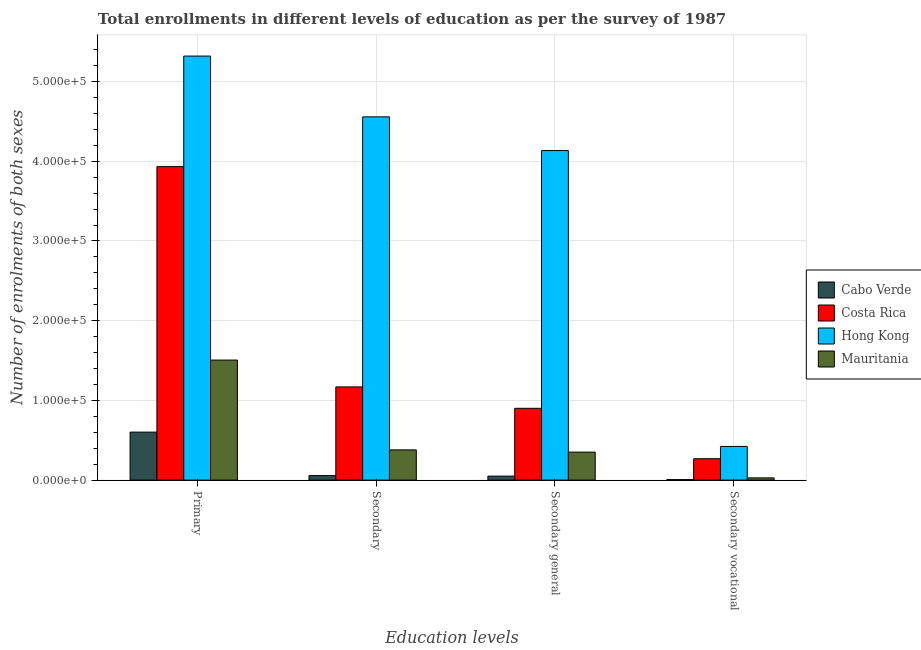How many different coloured bars are there?
Provide a short and direct response. 4. How many groups of bars are there?
Your response must be concise. 4. Are the number of bars per tick equal to the number of legend labels?
Provide a short and direct response. Yes. What is the label of the 2nd group of bars from the left?
Your response must be concise. Secondary. What is the number of enrolments in secondary general education in Costa Rica?
Offer a terse response. 9.01e+04. Across all countries, what is the maximum number of enrolments in secondary vocational education?
Your answer should be compact. 4.23e+04. Across all countries, what is the minimum number of enrolments in secondary education?
Provide a succinct answer. 5675. In which country was the number of enrolments in primary education maximum?
Make the answer very short. Hong Kong. In which country was the number of enrolments in secondary education minimum?
Offer a terse response. Cabo Verde. What is the total number of enrolments in primary education in the graph?
Keep it short and to the point. 1.14e+06. What is the difference between the number of enrolments in primary education in Cabo Verde and that in Costa Rica?
Provide a short and direct response. -3.33e+05. What is the difference between the number of enrolments in primary education in Mauritania and the number of enrolments in secondary general education in Cabo Verde?
Give a very brief answer. 1.46e+05. What is the average number of enrolments in primary education per country?
Ensure brevity in your answer.  2.84e+05. What is the difference between the number of enrolments in secondary general education and number of enrolments in primary education in Costa Rica?
Give a very brief answer. -3.03e+05. In how many countries, is the number of enrolments in primary education greater than 380000 ?
Your answer should be very brief. 2. What is the ratio of the number of enrolments in secondary general education in Cabo Verde to that in Costa Rica?
Your response must be concise. 0.06. Is the difference between the number of enrolments in secondary general education in Hong Kong and Costa Rica greater than the difference between the number of enrolments in secondary education in Hong Kong and Costa Rica?
Provide a short and direct response. No. What is the difference between the highest and the second highest number of enrolments in primary education?
Provide a succinct answer. 1.39e+05. What is the difference between the highest and the lowest number of enrolments in secondary education?
Your answer should be compact. 4.50e+05. In how many countries, is the number of enrolments in primary education greater than the average number of enrolments in primary education taken over all countries?
Your answer should be compact. 2. Is the sum of the number of enrolments in secondary education in Mauritania and Hong Kong greater than the maximum number of enrolments in secondary vocational education across all countries?
Provide a succinct answer. Yes. What does the 3rd bar from the left in Secondary vocational represents?
Your response must be concise. Hong Kong. What does the 1st bar from the right in Secondary represents?
Provide a short and direct response. Mauritania. Is it the case that in every country, the sum of the number of enrolments in primary education and number of enrolments in secondary education is greater than the number of enrolments in secondary general education?
Your response must be concise. Yes. Are the values on the major ticks of Y-axis written in scientific E-notation?
Offer a terse response. Yes. Where does the legend appear in the graph?
Your answer should be very brief. Center right. How many legend labels are there?
Your answer should be very brief. 4. What is the title of the graph?
Provide a short and direct response. Total enrollments in different levels of education as per the survey of 1987. What is the label or title of the X-axis?
Offer a very short reply. Education levels. What is the label or title of the Y-axis?
Keep it short and to the point. Number of enrolments of both sexes. What is the Number of enrolments of both sexes in Cabo Verde in Primary?
Your answer should be very brief. 6.02e+04. What is the Number of enrolments of both sexes in Costa Rica in Primary?
Your answer should be compact. 3.93e+05. What is the Number of enrolments of both sexes in Hong Kong in Primary?
Your answer should be compact. 5.32e+05. What is the Number of enrolments of both sexes of Mauritania in Primary?
Make the answer very short. 1.51e+05. What is the Number of enrolments of both sexes of Cabo Verde in Secondary?
Give a very brief answer. 5675. What is the Number of enrolments of both sexes in Costa Rica in Secondary?
Offer a very short reply. 1.17e+05. What is the Number of enrolments of both sexes in Hong Kong in Secondary?
Offer a very short reply. 4.56e+05. What is the Number of enrolments of both sexes in Mauritania in Secondary?
Keep it short and to the point. 3.79e+04. What is the Number of enrolments of both sexes in Cabo Verde in Secondary general?
Ensure brevity in your answer.  5026. What is the Number of enrolments of both sexes in Costa Rica in Secondary general?
Make the answer very short. 9.01e+04. What is the Number of enrolments of both sexes of Hong Kong in Secondary general?
Give a very brief answer. 4.13e+05. What is the Number of enrolments of both sexes in Mauritania in Secondary general?
Offer a very short reply. 3.51e+04. What is the Number of enrolments of both sexes in Cabo Verde in Secondary vocational?
Your answer should be compact. 649. What is the Number of enrolments of both sexes of Costa Rica in Secondary vocational?
Provide a short and direct response. 2.68e+04. What is the Number of enrolments of both sexes in Hong Kong in Secondary vocational?
Your response must be concise. 4.23e+04. What is the Number of enrolments of both sexes in Mauritania in Secondary vocational?
Ensure brevity in your answer.  2808. Across all Education levels, what is the maximum Number of enrolments of both sexes of Cabo Verde?
Offer a terse response. 6.02e+04. Across all Education levels, what is the maximum Number of enrolments of both sexes of Costa Rica?
Ensure brevity in your answer.  3.93e+05. Across all Education levels, what is the maximum Number of enrolments of both sexes of Hong Kong?
Offer a terse response. 5.32e+05. Across all Education levels, what is the maximum Number of enrolments of both sexes of Mauritania?
Your response must be concise. 1.51e+05. Across all Education levels, what is the minimum Number of enrolments of both sexes of Cabo Verde?
Give a very brief answer. 649. Across all Education levels, what is the minimum Number of enrolments of both sexes in Costa Rica?
Your answer should be compact. 2.68e+04. Across all Education levels, what is the minimum Number of enrolments of both sexes of Hong Kong?
Make the answer very short. 4.23e+04. Across all Education levels, what is the minimum Number of enrolments of both sexes of Mauritania?
Keep it short and to the point. 2808. What is the total Number of enrolments of both sexes of Cabo Verde in the graph?
Your answer should be compact. 7.16e+04. What is the total Number of enrolments of both sexes in Costa Rica in the graph?
Give a very brief answer. 6.27e+05. What is the total Number of enrolments of both sexes in Hong Kong in the graph?
Give a very brief answer. 1.44e+06. What is the total Number of enrolments of both sexes in Mauritania in the graph?
Offer a terse response. 2.26e+05. What is the difference between the Number of enrolments of both sexes in Cabo Verde in Primary and that in Secondary?
Your answer should be compact. 5.46e+04. What is the difference between the Number of enrolments of both sexes of Costa Rica in Primary and that in Secondary?
Your response must be concise. 2.76e+05. What is the difference between the Number of enrolments of both sexes of Hong Kong in Primary and that in Secondary?
Offer a very short reply. 7.63e+04. What is the difference between the Number of enrolments of both sexes of Mauritania in Primary and that in Secondary?
Make the answer very short. 1.13e+05. What is the difference between the Number of enrolments of both sexes in Cabo Verde in Primary and that in Secondary general?
Offer a terse response. 5.52e+04. What is the difference between the Number of enrolments of both sexes of Costa Rica in Primary and that in Secondary general?
Provide a short and direct response. 3.03e+05. What is the difference between the Number of enrolments of both sexes in Hong Kong in Primary and that in Secondary general?
Provide a succinct answer. 1.19e+05. What is the difference between the Number of enrolments of both sexes in Mauritania in Primary and that in Secondary general?
Provide a succinct answer. 1.15e+05. What is the difference between the Number of enrolments of both sexes in Cabo Verde in Primary and that in Secondary vocational?
Keep it short and to the point. 5.96e+04. What is the difference between the Number of enrolments of both sexes in Costa Rica in Primary and that in Secondary vocational?
Give a very brief answer. 3.66e+05. What is the difference between the Number of enrolments of both sexes in Hong Kong in Primary and that in Secondary vocational?
Offer a very short reply. 4.90e+05. What is the difference between the Number of enrolments of both sexes of Mauritania in Primary and that in Secondary vocational?
Offer a terse response. 1.48e+05. What is the difference between the Number of enrolments of both sexes of Cabo Verde in Secondary and that in Secondary general?
Your answer should be very brief. 649. What is the difference between the Number of enrolments of both sexes of Costa Rica in Secondary and that in Secondary general?
Ensure brevity in your answer.  2.68e+04. What is the difference between the Number of enrolments of both sexes of Hong Kong in Secondary and that in Secondary general?
Keep it short and to the point. 4.23e+04. What is the difference between the Number of enrolments of both sexes of Mauritania in Secondary and that in Secondary general?
Offer a very short reply. 2808. What is the difference between the Number of enrolments of both sexes of Cabo Verde in Secondary and that in Secondary vocational?
Offer a terse response. 5026. What is the difference between the Number of enrolments of both sexes of Costa Rica in Secondary and that in Secondary vocational?
Offer a very short reply. 9.01e+04. What is the difference between the Number of enrolments of both sexes in Hong Kong in Secondary and that in Secondary vocational?
Your response must be concise. 4.13e+05. What is the difference between the Number of enrolments of both sexes of Mauritania in Secondary and that in Secondary vocational?
Make the answer very short. 3.51e+04. What is the difference between the Number of enrolments of both sexes in Cabo Verde in Secondary general and that in Secondary vocational?
Make the answer very short. 4377. What is the difference between the Number of enrolments of both sexes in Costa Rica in Secondary general and that in Secondary vocational?
Provide a succinct answer. 6.33e+04. What is the difference between the Number of enrolments of both sexes in Hong Kong in Secondary general and that in Secondary vocational?
Your response must be concise. 3.71e+05. What is the difference between the Number of enrolments of both sexes in Mauritania in Secondary general and that in Secondary vocational?
Ensure brevity in your answer.  3.23e+04. What is the difference between the Number of enrolments of both sexes of Cabo Verde in Primary and the Number of enrolments of both sexes of Costa Rica in Secondary?
Your response must be concise. -5.67e+04. What is the difference between the Number of enrolments of both sexes in Cabo Verde in Primary and the Number of enrolments of both sexes in Hong Kong in Secondary?
Offer a terse response. -3.96e+05. What is the difference between the Number of enrolments of both sexes in Cabo Verde in Primary and the Number of enrolments of both sexes in Mauritania in Secondary?
Your response must be concise. 2.23e+04. What is the difference between the Number of enrolments of both sexes of Costa Rica in Primary and the Number of enrolments of both sexes of Hong Kong in Secondary?
Provide a short and direct response. -6.24e+04. What is the difference between the Number of enrolments of both sexes of Costa Rica in Primary and the Number of enrolments of both sexes of Mauritania in Secondary?
Provide a short and direct response. 3.55e+05. What is the difference between the Number of enrolments of both sexes in Hong Kong in Primary and the Number of enrolments of both sexes in Mauritania in Secondary?
Keep it short and to the point. 4.94e+05. What is the difference between the Number of enrolments of both sexes of Cabo Verde in Primary and the Number of enrolments of both sexes of Costa Rica in Secondary general?
Offer a very short reply. -2.99e+04. What is the difference between the Number of enrolments of both sexes of Cabo Verde in Primary and the Number of enrolments of both sexes of Hong Kong in Secondary general?
Your answer should be very brief. -3.53e+05. What is the difference between the Number of enrolments of both sexes of Cabo Verde in Primary and the Number of enrolments of both sexes of Mauritania in Secondary general?
Your answer should be compact. 2.51e+04. What is the difference between the Number of enrolments of both sexes in Costa Rica in Primary and the Number of enrolments of both sexes in Hong Kong in Secondary general?
Ensure brevity in your answer.  -2.02e+04. What is the difference between the Number of enrolments of both sexes in Costa Rica in Primary and the Number of enrolments of both sexes in Mauritania in Secondary general?
Offer a terse response. 3.58e+05. What is the difference between the Number of enrolments of both sexes in Hong Kong in Primary and the Number of enrolments of both sexes in Mauritania in Secondary general?
Your response must be concise. 4.97e+05. What is the difference between the Number of enrolments of both sexes of Cabo Verde in Primary and the Number of enrolments of both sexes of Costa Rica in Secondary vocational?
Provide a short and direct response. 3.34e+04. What is the difference between the Number of enrolments of both sexes in Cabo Verde in Primary and the Number of enrolments of both sexes in Hong Kong in Secondary vocational?
Offer a very short reply. 1.80e+04. What is the difference between the Number of enrolments of both sexes of Cabo Verde in Primary and the Number of enrolments of both sexes of Mauritania in Secondary vocational?
Offer a very short reply. 5.74e+04. What is the difference between the Number of enrolments of both sexes of Costa Rica in Primary and the Number of enrolments of both sexes of Hong Kong in Secondary vocational?
Keep it short and to the point. 3.51e+05. What is the difference between the Number of enrolments of both sexes of Costa Rica in Primary and the Number of enrolments of both sexes of Mauritania in Secondary vocational?
Your response must be concise. 3.90e+05. What is the difference between the Number of enrolments of both sexes of Hong Kong in Primary and the Number of enrolments of both sexes of Mauritania in Secondary vocational?
Provide a short and direct response. 5.29e+05. What is the difference between the Number of enrolments of both sexes in Cabo Verde in Secondary and the Number of enrolments of both sexes in Costa Rica in Secondary general?
Your response must be concise. -8.44e+04. What is the difference between the Number of enrolments of both sexes in Cabo Verde in Secondary and the Number of enrolments of both sexes in Hong Kong in Secondary general?
Make the answer very short. -4.08e+05. What is the difference between the Number of enrolments of both sexes of Cabo Verde in Secondary and the Number of enrolments of both sexes of Mauritania in Secondary general?
Your answer should be compact. -2.95e+04. What is the difference between the Number of enrolments of both sexes of Costa Rica in Secondary and the Number of enrolments of both sexes of Hong Kong in Secondary general?
Ensure brevity in your answer.  -2.97e+05. What is the difference between the Number of enrolments of both sexes of Costa Rica in Secondary and the Number of enrolments of both sexes of Mauritania in Secondary general?
Provide a succinct answer. 8.18e+04. What is the difference between the Number of enrolments of both sexes in Hong Kong in Secondary and the Number of enrolments of both sexes in Mauritania in Secondary general?
Ensure brevity in your answer.  4.21e+05. What is the difference between the Number of enrolments of both sexes of Cabo Verde in Secondary and the Number of enrolments of both sexes of Costa Rica in Secondary vocational?
Provide a short and direct response. -2.12e+04. What is the difference between the Number of enrolments of both sexes in Cabo Verde in Secondary and the Number of enrolments of both sexes in Hong Kong in Secondary vocational?
Your response must be concise. -3.66e+04. What is the difference between the Number of enrolments of both sexes of Cabo Verde in Secondary and the Number of enrolments of both sexes of Mauritania in Secondary vocational?
Make the answer very short. 2867. What is the difference between the Number of enrolments of both sexes of Costa Rica in Secondary and the Number of enrolments of both sexes of Hong Kong in Secondary vocational?
Ensure brevity in your answer.  7.47e+04. What is the difference between the Number of enrolments of both sexes in Costa Rica in Secondary and the Number of enrolments of both sexes in Mauritania in Secondary vocational?
Keep it short and to the point. 1.14e+05. What is the difference between the Number of enrolments of both sexes in Hong Kong in Secondary and the Number of enrolments of both sexes in Mauritania in Secondary vocational?
Your answer should be compact. 4.53e+05. What is the difference between the Number of enrolments of both sexes of Cabo Verde in Secondary general and the Number of enrolments of both sexes of Costa Rica in Secondary vocational?
Offer a very short reply. -2.18e+04. What is the difference between the Number of enrolments of both sexes in Cabo Verde in Secondary general and the Number of enrolments of both sexes in Hong Kong in Secondary vocational?
Your answer should be compact. -3.72e+04. What is the difference between the Number of enrolments of both sexes of Cabo Verde in Secondary general and the Number of enrolments of both sexes of Mauritania in Secondary vocational?
Provide a succinct answer. 2218. What is the difference between the Number of enrolments of both sexes in Costa Rica in Secondary general and the Number of enrolments of both sexes in Hong Kong in Secondary vocational?
Give a very brief answer. 4.78e+04. What is the difference between the Number of enrolments of both sexes in Costa Rica in Secondary general and the Number of enrolments of both sexes in Mauritania in Secondary vocational?
Ensure brevity in your answer.  8.73e+04. What is the difference between the Number of enrolments of both sexes of Hong Kong in Secondary general and the Number of enrolments of both sexes of Mauritania in Secondary vocational?
Make the answer very short. 4.11e+05. What is the average Number of enrolments of both sexes of Cabo Verde per Education levels?
Your answer should be very brief. 1.79e+04. What is the average Number of enrolments of both sexes in Costa Rica per Education levels?
Provide a succinct answer. 1.57e+05. What is the average Number of enrolments of both sexes of Hong Kong per Education levels?
Your answer should be compact. 3.61e+05. What is the average Number of enrolments of both sexes in Mauritania per Education levels?
Provide a short and direct response. 5.66e+04. What is the difference between the Number of enrolments of both sexes of Cabo Verde and Number of enrolments of both sexes of Costa Rica in Primary?
Ensure brevity in your answer.  -3.33e+05. What is the difference between the Number of enrolments of both sexes of Cabo Verde and Number of enrolments of both sexes of Hong Kong in Primary?
Keep it short and to the point. -4.72e+05. What is the difference between the Number of enrolments of both sexes of Cabo Verde and Number of enrolments of both sexes of Mauritania in Primary?
Give a very brief answer. -9.04e+04. What is the difference between the Number of enrolments of both sexes of Costa Rica and Number of enrolments of both sexes of Hong Kong in Primary?
Make the answer very short. -1.39e+05. What is the difference between the Number of enrolments of both sexes of Costa Rica and Number of enrolments of both sexes of Mauritania in Primary?
Make the answer very short. 2.43e+05. What is the difference between the Number of enrolments of both sexes of Hong Kong and Number of enrolments of both sexes of Mauritania in Primary?
Offer a very short reply. 3.81e+05. What is the difference between the Number of enrolments of both sexes of Cabo Verde and Number of enrolments of both sexes of Costa Rica in Secondary?
Your answer should be compact. -1.11e+05. What is the difference between the Number of enrolments of both sexes in Cabo Verde and Number of enrolments of both sexes in Hong Kong in Secondary?
Provide a succinct answer. -4.50e+05. What is the difference between the Number of enrolments of both sexes in Cabo Verde and Number of enrolments of both sexes in Mauritania in Secondary?
Offer a very short reply. -3.23e+04. What is the difference between the Number of enrolments of both sexes in Costa Rica and Number of enrolments of both sexes in Hong Kong in Secondary?
Your answer should be very brief. -3.39e+05. What is the difference between the Number of enrolments of both sexes of Costa Rica and Number of enrolments of both sexes of Mauritania in Secondary?
Give a very brief answer. 7.90e+04. What is the difference between the Number of enrolments of both sexes in Hong Kong and Number of enrolments of both sexes in Mauritania in Secondary?
Your response must be concise. 4.18e+05. What is the difference between the Number of enrolments of both sexes in Cabo Verde and Number of enrolments of both sexes in Costa Rica in Secondary general?
Give a very brief answer. -8.51e+04. What is the difference between the Number of enrolments of both sexes in Cabo Verde and Number of enrolments of both sexes in Hong Kong in Secondary general?
Your response must be concise. -4.08e+05. What is the difference between the Number of enrolments of both sexes in Cabo Verde and Number of enrolments of both sexes in Mauritania in Secondary general?
Give a very brief answer. -3.01e+04. What is the difference between the Number of enrolments of both sexes in Costa Rica and Number of enrolments of both sexes in Hong Kong in Secondary general?
Provide a short and direct response. -3.23e+05. What is the difference between the Number of enrolments of both sexes of Costa Rica and Number of enrolments of both sexes of Mauritania in Secondary general?
Your answer should be very brief. 5.50e+04. What is the difference between the Number of enrolments of both sexes in Hong Kong and Number of enrolments of both sexes in Mauritania in Secondary general?
Provide a short and direct response. 3.78e+05. What is the difference between the Number of enrolments of both sexes in Cabo Verde and Number of enrolments of both sexes in Costa Rica in Secondary vocational?
Offer a very short reply. -2.62e+04. What is the difference between the Number of enrolments of both sexes of Cabo Verde and Number of enrolments of both sexes of Hong Kong in Secondary vocational?
Offer a terse response. -4.16e+04. What is the difference between the Number of enrolments of both sexes of Cabo Verde and Number of enrolments of both sexes of Mauritania in Secondary vocational?
Your answer should be compact. -2159. What is the difference between the Number of enrolments of both sexes of Costa Rica and Number of enrolments of both sexes of Hong Kong in Secondary vocational?
Provide a short and direct response. -1.54e+04. What is the difference between the Number of enrolments of both sexes in Costa Rica and Number of enrolments of both sexes in Mauritania in Secondary vocational?
Your response must be concise. 2.40e+04. What is the difference between the Number of enrolments of both sexes of Hong Kong and Number of enrolments of both sexes of Mauritania in Secondary vocational?
Your answer should be very brief. 3.95e+04. What is the ratio of the Number of enrolments of both sexes in Cabo Verde in Primary to that in Secondary?
Keep it short and to the point. 10.61. What is the ratio of the Number of enrolments of both sexes in Costa Rica in Primary to that in Secondary?
Your answer should be very brief. 3.36. What is the ratio of the Number of enrolments of both sexes in Hong Kong in Primary to that in Secondary?
Offer a very short reply. 1.17. What is the ratio of the Number of enrolments of both sexes of Mauritania in Primary to that in Secondary?
Provide a succinct answer. 3.97. What is the ratio of the Number of enrolments of both sexes in Cabo Verde in Primary to that in Secondary general?
Your answer should be compact. 11.98. What is the ratio of the Number of enrolments of both sexes of Costa Rica in Primary to that in Secondary general?
Your response must be concise. 4.37. What is the ratio of the Number of enrolments of both sexes in Hong Kong in Primary to that in Secondary general?
Your answer should be compact. 1.29. What is the ratio of the Number of enrolments of both sexes of Mauritania in Primary to that in Secondary general?
Your response must be concise. 4.29. What is the ratio of the Number of enrolments of both sexes of Cabo Verde in Primary to that in Secondary vocational?
Give a very brief answer. 92.8. What is the ratio of the Number of enrolments of both sexes in Costa Rica in Primary to that in Secondary vocational?
Your response must be concise. 14.66. What is the ratio of the Number of enrolments of both sexes in Hong Kong in Primary to that in Secondary vocational?
Your answer should be compact. 12.59. What is the ratio of the Number of enrolments of both sexes of Mauritania in Primary to that in Secondary vocational?
Offer a very short reply. 53.63. What is the ratio of the Number of enrolments of both sexes of Cabo Verde in Secondary to that in Secondary general?
Offer a very short reply. 1.13. What is the ratio of the Number of enrolments of both sexes of Costa Rica in Secondary to that in Secondary general?
Ensure brevity in your answer.  1.3. What is the ratio of the Number of enrolments of both sexes of Hong Kong in Secondary to that in Secondary general?
Your answer should be compact. 1.1. What is the ratio of the Number of enrolments of both sexes of Mauritania in Secondary to that in Secondary general?
Provide a succinct answer. 1.08. What is the ratio of the Number of enrolments of both sexes of Cabo Verde in Secondary to that in Secondary vocational?
Provide a short and direct response. 8.74. What is the ratio of the Number of enrolments of both sexes in Costa Rica in Secondary to that in Secondary vocational?
Provide a short and direct response. 4.36. What is the ratio of the Number of enrolments of both sexes in Hong Kong in Secondary to that in Secondary vocational?
Offer a terse response. 10.78. What is the ratio of the Number of enrolments of both sexes of Mauritania in Secondary to that in Secondary vocational?
Offer a terse response. 13.51. What is the ratio of the Number of enrolments of both sexes in Cabo Verde in Secondary general to that in Secondary vocational?
Your response must be concise. 7.74. What is the ratio of the Number of enrolments of both sexes in Costa Rica in Secondary general to that in Secondary vocational?
Ensure brevity in your answer.  3.36. What is the ratio of the Number of enrolments of both sexes in Hong Kong in Secondary general to that in Secondary vocational?
Ensure brevity in your answer.  9.78. What is the ratio of the Number of enrolments of both sexes in Mauritania in Secondary general to that in Secondary vocational?
Make the answer very short. 12.51. What is the difference between the highest and the second highest Number of enrolments of both sexes of Cabo Verde?
Your response must be concise. 5.46e+04. What is the difference between the highest and the second highest Number of enrolments of both sexes of Costa Rica?
Your answer should be compact. 2.76e+05. What is the difference between the highest and the second highest Number of enrolments of both sexes of Hong Kong?
Keep it short and to the point. 7.63e+04. What is the difference between the highest and the second highest Number of enrolments of both sexes in Mauritania?
Ensure brevity in your answer.  1.13e+05. What is the difference between the highest and the lowest Number of enrolments of both sexes of Cabo Verde?
Provide a succinct answer. 5.96e+04. What is the difference between the highest and the lowest Number of enrolments of both sexes of Costa Rica?
Offer a very short reply. 3.66e+05. What is the difference between the highest and the lowest Number of enrolments of both sexes in Hong Kong?
Your answer should be very brief. 4.90e+05. What is the difference between the highest and the lowest Number of enrolments of both sexes in Mauritania?
Provide a succinct answer. 1.48e+05. 